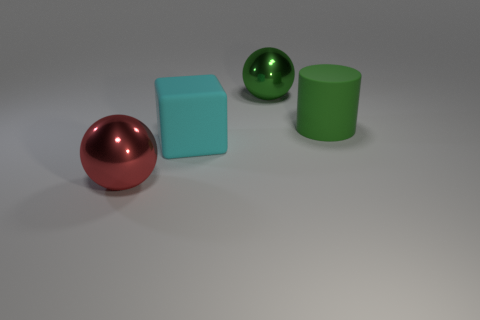Add 4 brown balls. How many objects exist? 8 Subtract all purple balls. Subtract all green cylinders. How many balls are left? 2 Subtract all red objects. Subtract all large red spheres. How many objects are left? 2 Add 1 cubes. How many cubes are left? 2 Add 4 matte objects. How many matte objects exist? 6 Subtract 0 gray balls. How many objects are left? 4 